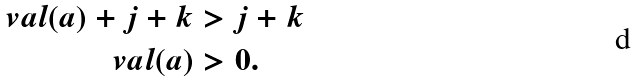<formula> <loc_0><loc_0><loc_500><loc_500>\ v a l ( a ) + j + k & > j + k \\ \ v a l ( a ) & > 0 .</formula> 